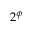<formula> <loc_0><loc_0><loc_500><loc_500>2 ^ { \phi }</formula> 